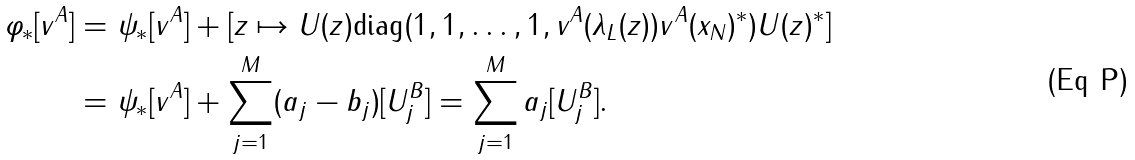<formula> <loc_0><loc_0><loc_500><loc_500>\varphi _ { * } [ v ^ { A } ] = & \ \psi _ { * } [ v ^ { A } ] + [ z \mapsto U ( z ) \text {diag} ( 1 , 1 , \dots , 1 , v ^ { A } ( \lambda _ { L } ( z ) ) v ^ { A } ( x _ { N } ) ^ { * } ) U ( z ) ^ { * } ] \\ = & \ \psi _ { * } [ v ^ { A } ] + \sum _ { j = 1 } ^ { M } ( a _ { j } - b _ { j } ) [ U _ { j } ^ { B } ] = \sum _ { j = 1 } ^ { M } a _ { j } [ U _ { j } ^ { B } ] .</formula> 